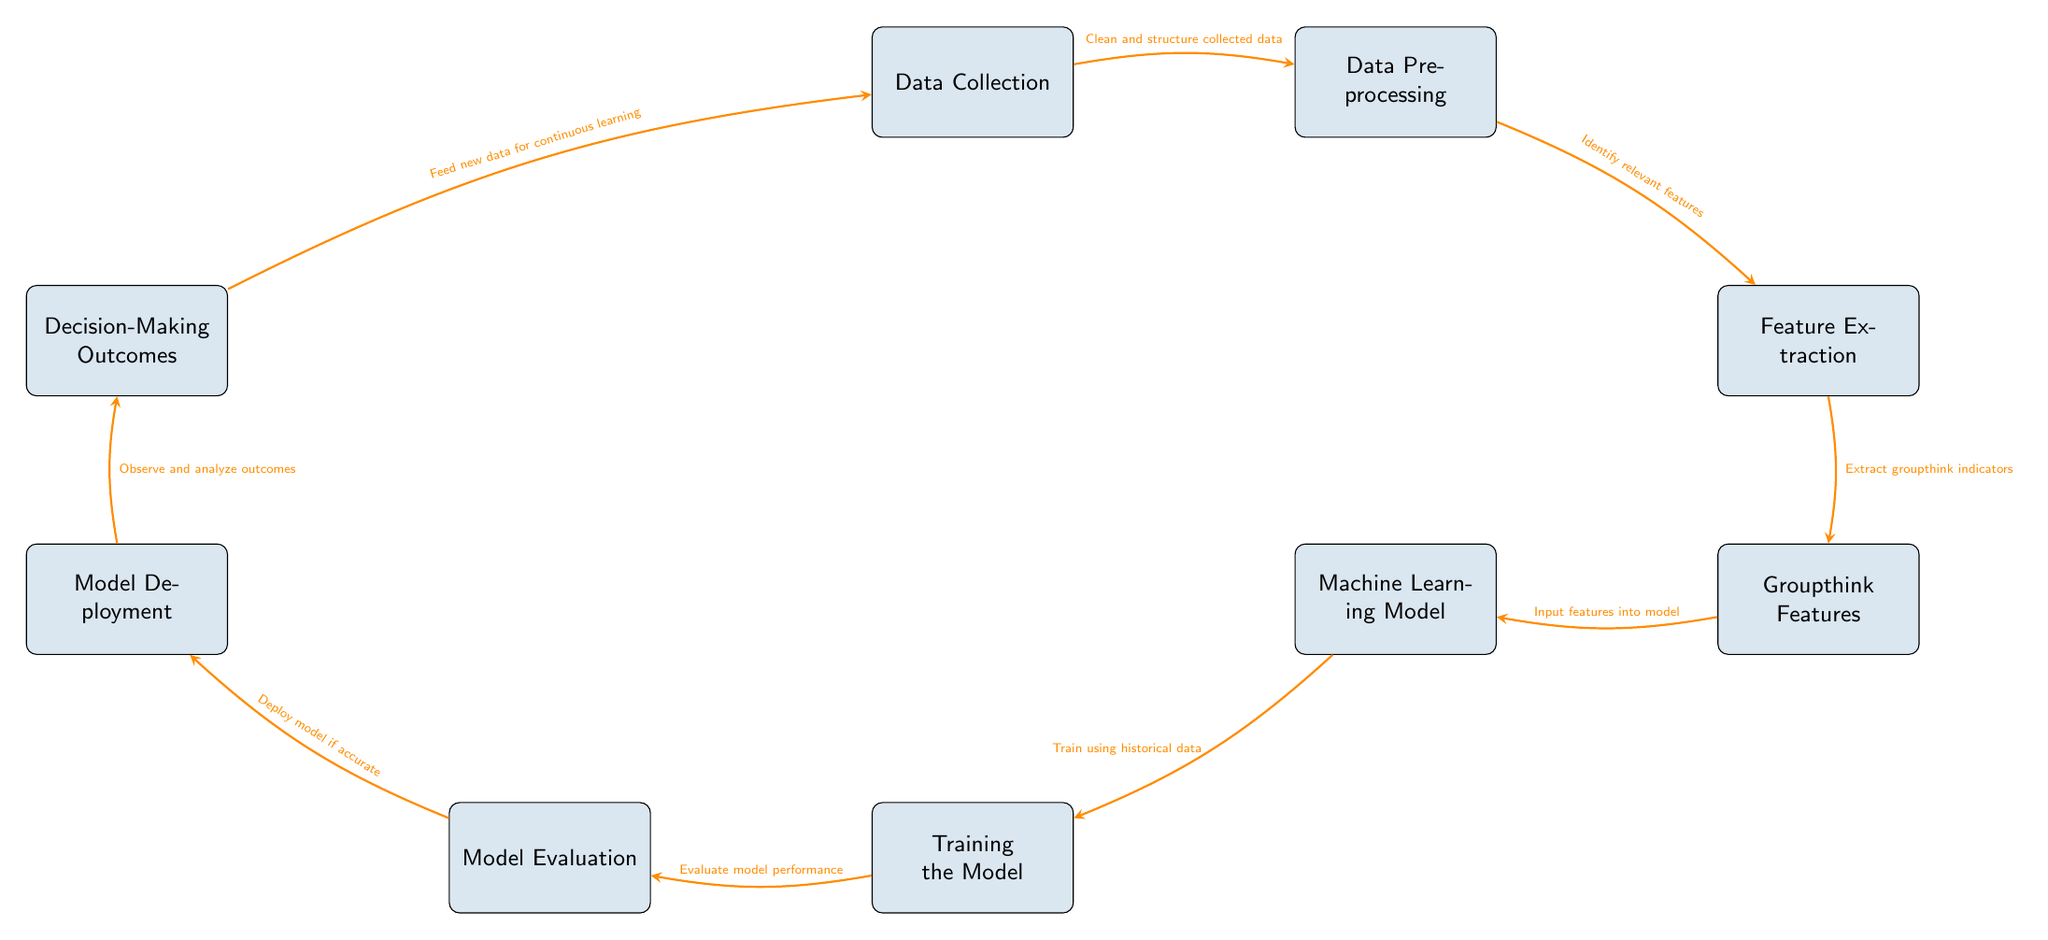what are the first two steps in the predictive model analysis? The first two steps are "Data Collection" followed by "Data Preprocessing." These nodes are positioned sequentially at the top of the diagram, illustrating the order of operations in the workflow.
Answer: Data Collection, Data Preprocessing how many main nodes are present in the diagram? Counting the main nodes shown, there are a total of seven nodes, each representing distinct steps in the predictive model analysis process.
Answer: 7 which node directly follows "Feature Extraction"? "Groupthink Features" is the node that directly follows "Feature Extraction," as indicated by the arrow connecting these two nodes in the diagram.
Answer: Groupthink Features what is the output of the "Model Evaluation" node? The output involves "Deploy model if accurate." This indicates that if the model's performance meets the necessary standards, it will be deployed.
Answer: Deploy model if accurate what is the function of the "Training the Model" node? The node "Training the Model" serves the purpose of "Train using historical data," indicating it uses past data to improve model performance.
Answer: Train using historical data explain the flow from "Decision-Making Outcomes" back to "Data Collection." The flow from "Decision-Making Outcomes" to "Data Collection" is represented by an arrow stating "Feed new data for continuous learning." This means that insights gained from outcomes are fed back into the data collection process, allowing for ongoing refinement and improvement of the model.
Answer: Feed new data for continuous learning what step comes after "Model Deployment"? The step that comes after "Model Deployment" is "Observe and analyze outcomes." This indicates that once a model is deployed, the effects and results of its use are monitored and analyzed.
Answer: Observe and analyze outcomes how do "Groupthink Features" influence the model? "Groupthink Features" provide the critical "Input features into model," which are necessary for the machine learning model to operate effectively. They act as key components that the model uses to make predictions.
Answer: Input features into model 